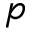<formula> <loc_0><loc_0><loc_500><loc_500>p</formula> 